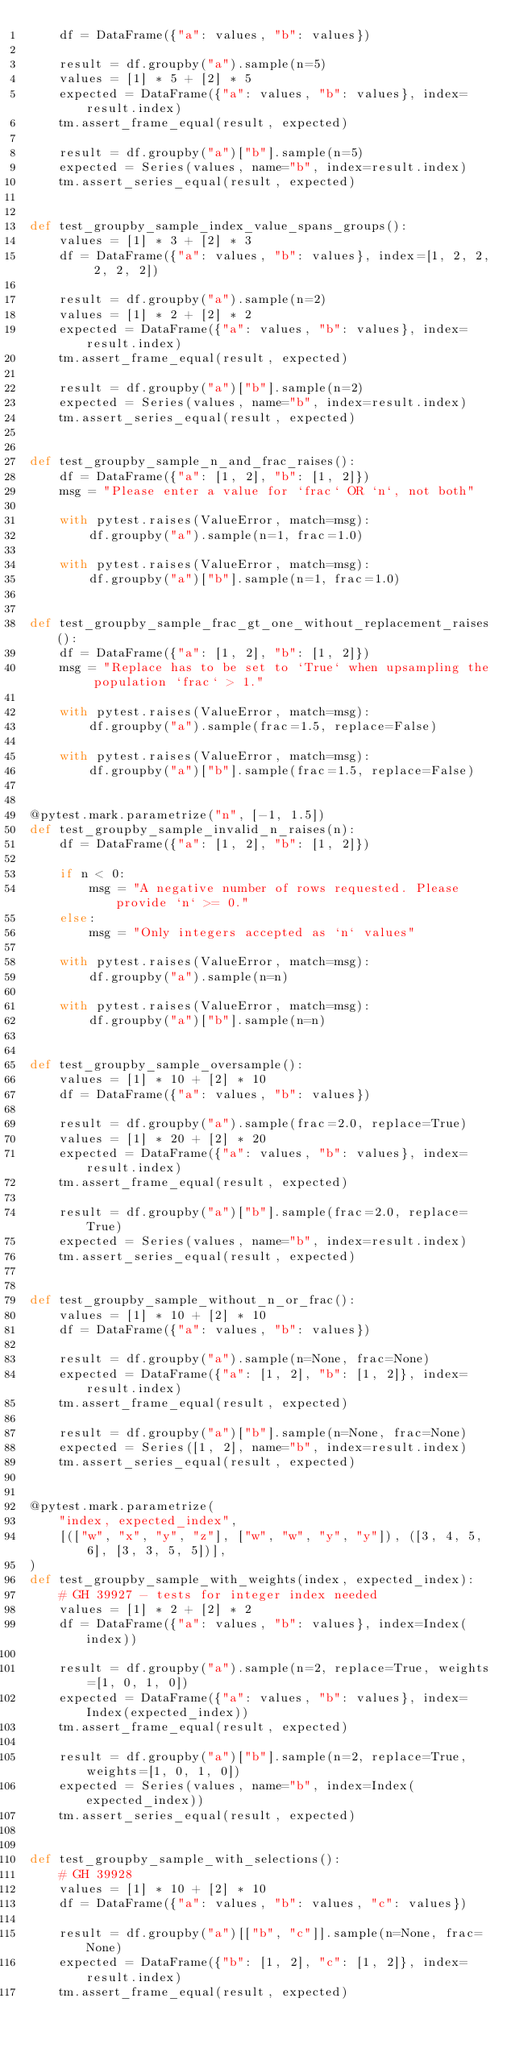Convert code to text. <code><loc_0><loc_0><loc_500><loc_500><_Python_>    df = DataFrame({"a": values, "b": values})

    result = df.groupby("a").sample(n=5)
    values = [1] * 5 + [2] * 5
    expected = DataFrame({"a": values, "b": values}, index=result.index)
    tm.assert_frame_equal(result, expected)

    result = df.groupby("a")["b"].sample(n=5)
    expected = Series(values, name="b", index=result.index)
    tm.assert_series_equal(result, expected)


def test_groupby_sample_index_value_spans_groups():
    values = [1] * 3 + [2] * 3
    df = DataFrame({"a": values, "b": values}, index=[1, 2, 2, 2, 2, 2])

    result = df.groupby("a").sample(n=2)
    values = [1] * 2 + [2] * 2
    expected = DataFrame({"a": values, "b": values}, index=result.index)
    tm.assert_frame_equal(result, expected)

    result = df.groupby("a")["b"].sample(n=2)
    expected = Series(values, name="b", index=result.index)
    tm.assert_series_equal(result, expected)


def test_groupby_sample_n_and_frac_raises():
    df = DataFrame({"a": [1, 2], "b": [1, 2]})
    msg = "Please enter a value for `frac` OR `n`, not both"

    with pytest.raises(ValueError, match=msg):
        df.groupby("a").sample(n=1, frac=1.0)

    with pytest.raises(ValueError, match=msg):
        df.groupby("a")["b"].sample(n=1, frac=1.0)


def test_groupby_sample_frac_gt_one_without_replacement_raises():
    df = DataFrame({"a": [1, 2], "b": [1, 2]})
    msg = "Replace has to be set to `True` when upsampling the population `frac` > 1."

    with pytest.raises(ValueError, match=msg):
        df.groupby("a").sample(frac=1.5, replace=False)

    with pytest.raises(ValueError, match=msg):
        df.groupby("a")["b"].sample(frac=1.5, replace=False)


@pytest.mark.parametrize("n", [-1, 1.5])
def test_groupby_sample_invalid_n_raises(n):
    df = DataFrame({"a": [1, 2], "b": [1, 2]})

    if n < 0:
        msg = "A negative number of rows requested. Please provide `n` >= 0."
    else:
        msg = "Only integers accepted as `n` values"

    with pytest.raises(ValueError, match=msg):
        df.groupby("a").sample(n=n)

    with pytest.raises(ValueError, match=msg):
        df.groupby("a")["b"].sample(n=n)


def test_groupby_sample_oversample():
    values = [1] * 10 + [2] * 10
    df = DataFrame({"a": values, "b": values})

    result = df.groupby("a").sample(frac=2.0, replace=True)
    values = [1] * 20 + [2] * 20
    expected = DataFrame({"a": values, "b": values}, index=result.index)
    tm.assert_frame_equal(result, expected)

    result = df.groupby("a")["b"].sample(frac=2.0, replace=True)
    expected = Series(values, name="b", index=result.index)
    tm.assert_series_equal(result, expected)


def test_groupby_sample_without_n_or_frac():
    values = [1] * 10 + [2] * 10
    df = DataFrame({"a": values, "b": values})

    result = df.groupby("a").sample(n=None, frac=None)
    expected = DataFrame({"a": [1, 2], "b": [1, 2]}, index=result.index)
    tm.assert_frame_equal(result, expected)

    result = df.groupby("a")["b"].sample(n=None, frac=None)
    expected = Series([1, 2], name="b", index=result.index)
    tm.assert_series_equal(result, expected)


@pytest.mark.parametrize(
    "index, expected_index",
    [(["w", "x", "y", "z"], ["w", "w", "y", "y"]), ([3, 4, 5, 6], [3, 3, 5, 5])],
)
def test_groupby_sample_with_weights(index, expected_index):
    # GH 39927 - tests for integer index needed
    values = [1] * 2 + [2] * 2
    df = DataFrame({"a": values, "b": values}, index=Index(index))

    result = df.groupby("a").sample(n=2, replace=True, weights=[1, 0, 1, 0])
    expected = DataFrame({"a": values, "b": values}, index=Index(expected_index))
    tm.assert_frame_equal(result, expected)

    result = df.groupby("a")["b"].sample(n=2, replace=True, weights=[1, 0, 1, 0])
    expected = Series(values, name="b", index=Index(expected_index))
    tm.assert_series_equal(result, expected)


def test_groupby_sample_with_selections():
    # GH 39928
    values = [1] * 10 + [2] * 10
    df = DataFrame({"a": values, "b": values, "c": values})

    result = df.groupby("a")[["b", "c"]].sample(n=None, frac=None)
    expected = DataFrame({"b": [1, 2], "c": [1, 2]}, index=result.index)
    tm.assert_frame_equal(result, expected)
</code> 